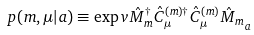Convert formula to latex. <formula><loc_0><loc_0><loc_500><loc_500>p ( m , \mu | a ) \equiv \exp v { \hat { M } _ { m } ^ { \dagger } \hat { C } ^ { ( m ) \dagger } _ { \mu } \hat { C } ^ { ( m ) } _ { \mu } \hat { M } _ { m } } _ { a }</formula> 